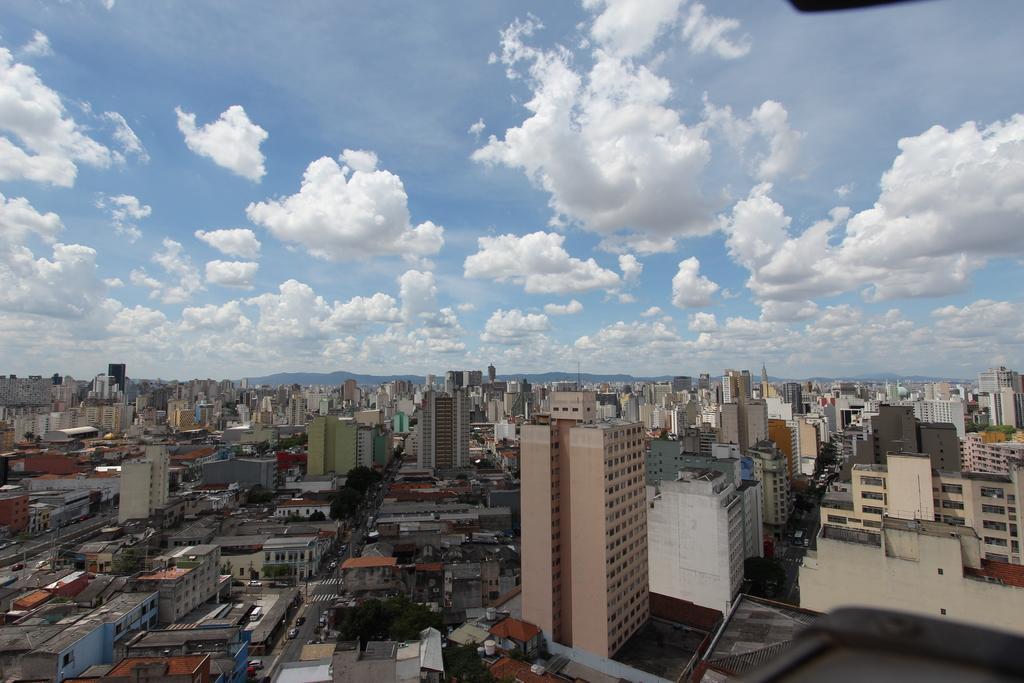Can you describe this image briefly? In this picture we can observe some buildings. There are some roads. We can observe some vehicles on these roads. In the background there are hills and a sky with some clouds. 